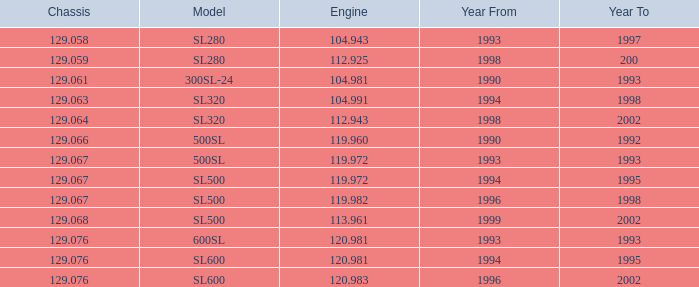Can you parse all the data within this table? {'header': ['Chassis', 'Model', 'Engine', 'Year From', 'Year To'], 'rows': [['129.058', 'SL280', '104.943', '1993', '1997'], ['129.059', 'SL280', '112.925', '1998', '200'], ['129.061', '300SL-24', '104.981', '1990', '1993'], ['129.063', 'SL320', '104.991', '1994', '1998'], ['129.064', 'SL320', '112.943', '1998', '2002'], ['129.066', '500SL', '119.960', '1990', '1992'], ['129.067', '500SL', '119.972', '1993', '1993'], ['129.067', 'SL500', '119.972', '1994', '1995'], ['129.067', 'SL500', '119.982', '1996', '1998'], ['129.068', 'SL500', '113.961', '1999', '2002'], ['129.076', '600SL', '120.981', '1993', '1993'], ['129.076', 'SL600', '120.981', '1994', '1995'], ['129.076', 'SL600', '120.983', '1996', '2002']]} Which Engine has a Model of sl500, and a Year From larger than 1999? None. 